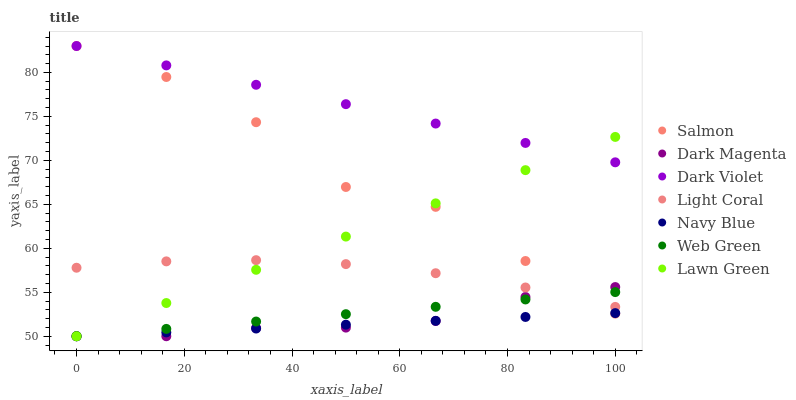Does Navy Blue have the minimum area under the curve?
Answer yes or no. Yes. Does Dark Violet have the maximum area under the curve?
Answer yes or no. Yes. Does Dark Magenta have the minimum area under the curve?
Answer yes or no. No. Does Dark Magenta have the maximum area under the curve?
Answer yes or no. No. Is Navy Blue the smoothest?
Answer yes or no. Yes. Is Salmon the roughest?
Answer yes or no. Yes. Is Dark Magenta the smoothest?
Answer yes or no. No. Is Dark Magenta the roughest?
Answer yes or no. No. Does Lawn Green have the lowest value?
Answer yes or no. Yes. Does Salmon have the lowest value?
Answer yes or no. No. Does Dark Violet have the highest value?
Answer yes or no. Yes. Does Dark Magenta have the highest value?
Answer yes or no. No. Is Light Coral less than Dark Violet?
Answer yes or no. Yes. Is Dark Violet greater than Dark Magenta?
Answer yes or no. Yes. Does Navy Blue intersect Salmon?
Answer yes or no. Yes. Is Navy Blue less than Salmon?
Answer yes or no. No. Is Navy Blue greater than Salmon?
Answer yes or no. No. Does Light Coral intersect Dark Violet?
Answer yes or no. No. 